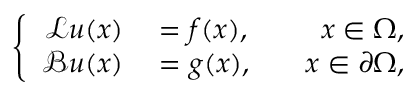Convert formula to latex. <formula><loc_0><loc_0><loc_500><loc_500>\left \{ \begin{array} { r l r } { \mathcal { L } u ( x ) } & = f ( x ) , } & { \quad x \in \Omega , } \\ { \mathcal { B } u ( x ) } & = g ( x ) , } & { \quad x \in \partial \Omega , } \end{array}</formula> 